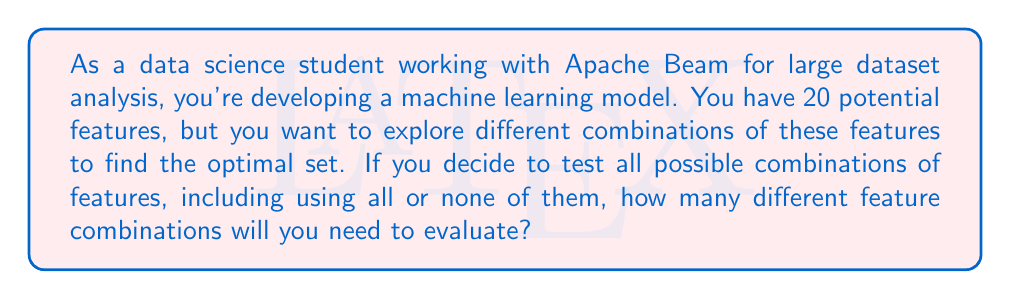What is the answer to this math problem? Let's approach this step-by-step:

1) Each feature has two possibilities: it's either included in the model or not. This is a binary choice for each feature.

2) We have 20 features in total, and for each feature, we're making an independent binary decision.

3) This scenario is perfectly suited for the multiplication principle of counting.

4) For each feature, we have 2 choices (include or exclude), and we're making this choice 20 times (once for each feature).

5) Therefore, the total number of combinations is:

   $$2 \times 2 \times 2 \times ... \text{ (20 times) } ... \times 2 = 2^{20}$$

6) We can calculate this:

   $$2^{20} = 1,048,576$$

7) This includes the cases where we use all features and where we use no features at all.

8) In the context of Apache Beam, you would likely need to create a pipeline that generates all these combinations and applies your model to each, which could be computationally intensive for large datasets.
Answer: $2^{20} = 1,048,576$ combinations 